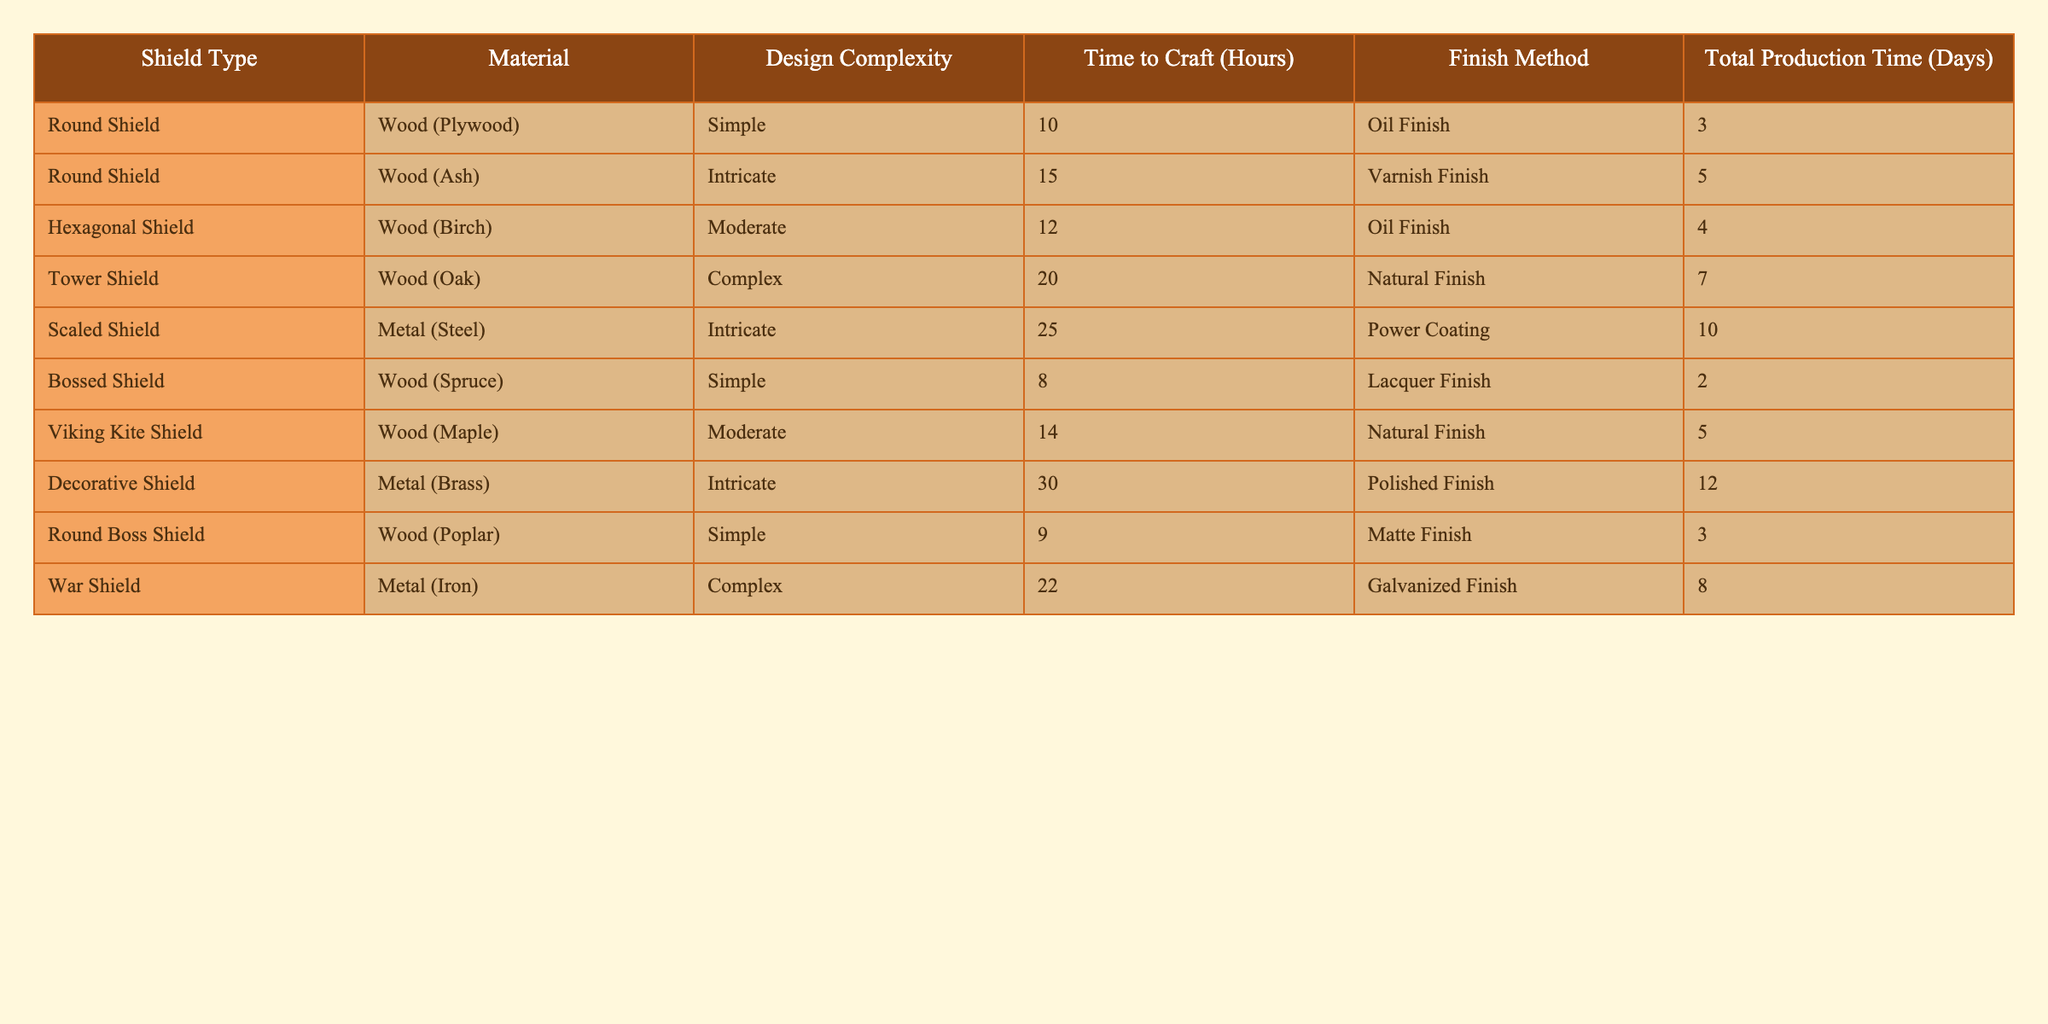What is the total production time for a Decorative Shield? The total production time is directly listed in the table for the Decorative Shield. According to the data, it takes 12 days to produce.
Answer: 12 days What materials are used to craft the Tower Shield? The materials column indicates that the Tower Shield is made of Wood (Oak).
Answer: Wood (Oak) How long does it take to craft a simple designed shield? The table shows the crafting time for simple designed shields: Round Shield (10 hours), Bossed Shield (8 hours), and Round Boss Shield (9 hours). The average is (10 + 8 + 9) / 3 = 9 hours.
Answer: 9 hours Which shield has the longest production time, and how many days does it take? The table lists all shields and their total production times. The Decorative Shield has the longest production time of 12 days.
Answer: Decorative Shield, 12 days Is the Total Production Time greater for Metal shields than for Wood shields? Total Production Time for Metal shields: Scaled (10 days) + War Shield (8 days) = 18 days. For Wood shields: Round Shield (3 days) + Round Boss Shield (3 days) + Tower Shield (7 days) + Hexagonal Shield (4 days) + Viking Kite Shield (5 days) + Bossed Shield (2 days) = 24 days. Thus, Metal shields have less total production time.
Answer: No What is the average Time to Craft for all the shields? To find the average, sum all the Time to Craft values: (10 + 15 + 12 + 20 + 25 + 8 + 14 + 30 + 9 + 22) = 165 hours. There are 10 shields, so average = 165 / 10 = 16.5 hours.
Answer: 16.5 hours How many types of shields are crafted using Metal? By counting in the Material column, there are 3 shields made of Metal (Scaled Shield, Decorative Shield, and War Shield).
Answer: 3 types What is the difference in crafting time between the simplest and the most complex design types? The simplest design time is 8 hours (Bossed Shield) and the most complex design time is 30 hours (Decorative Shield). The difference is 30 - 8 = 22 hours.
Answer: 22 hours Which finish method takes the longest time to complete? The table shows the finish methods, but it does not mention time taken for each method. However, we see that the shield with the longest total production time (Decorative Shield) involves the Polished Finish, which suggests it may take the longest comparatively, but definitive times for finishing methods aren't given. Therefore, it is not possible to answer this question based on the table.
Answer: Not determinable What is the shield type with the least Time to Craft? The table indicates that the Bossed Shield has the least Time to Craft, which is 8 hours.
Answer: Bossed Shield Is the average production time for shields made from Wood or Metal greater? Total Production Times for Wood shields (3+5+4+7+5+2 = 26 days) and Metal shields (10+12+8 = 30 days). Average for Wood = 26/6 = 4.33 days and for Metal = 30/3 = 10 days, meaning Metal shield's average time is greater.
Answer: Yes, Metal shields have a greater average 